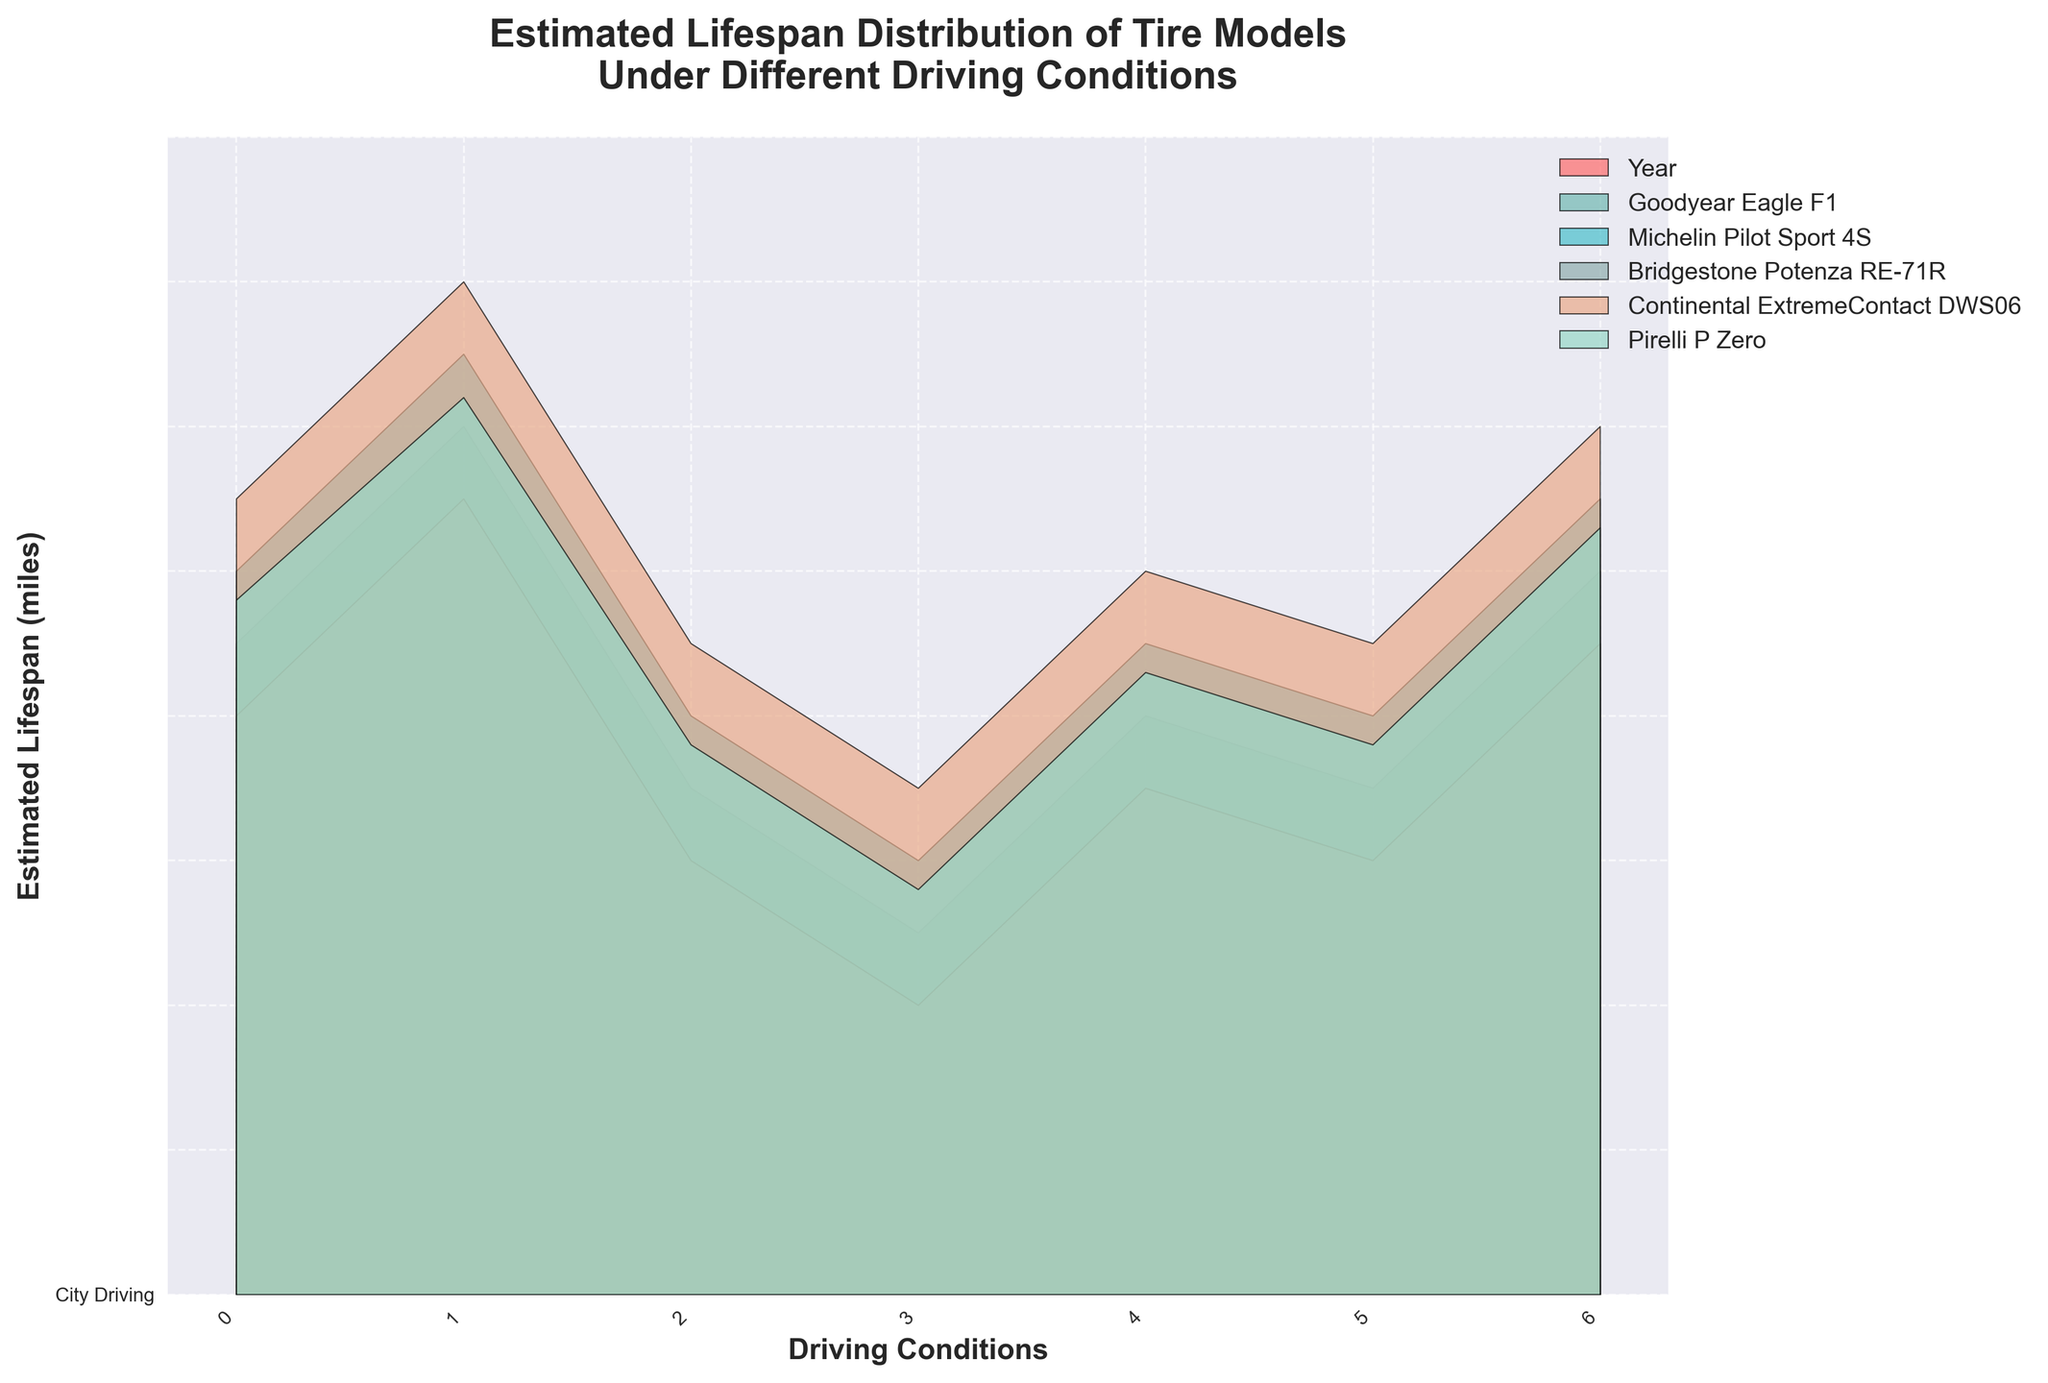What is the estimated lifespan of the Pirelli P Zero tires under city driving conditions? The estimated lifespan of the Pirelli P Zero tires under city driving conditions can be seen as the value corresponding to City Driving in the Pirelli P Zero line.
Answer: 48,000 miles Which tire model has the highest estimated lifespan under off-road driving conditions? Look at the off-road driving condition values for all tire models and compare them. The highest value is for Continental ExtremeContact DWS06.
Answer: Continental ExtremeContact DWS06 What is the difference in estimated lifespan of the Goodyear Eagle F1 between highway driving and wet conditions? The estimated lifespan for the Goodyear Eagle F1 in highway driving is 60,000 miles, and in wet conditions, it's 40,000 miles. The difference is 60,000 - 40,000.
Answer: 20,000 miles Which driving condition provides the lowest estimated lifespan for Bridgestone Potenza RE-71R tires? Compare the values for Bridgestone Potenza RE-71R across all driving conditions. Performance Driving has the lowest value.
Answer: Performance Driving What is the average estimated lifespan of Michelin Pilot Sport 4S under city, highway, and off-road driving conditions? Add the lifespans under city (50,000), highway (65,000), and off-road (30,000) driving conditions and divide by the number of conditions (3). (50,000 + 65,000 + 30,000)/3
Answer: 48,333 miles Under which climate condition do Goodyear Eagle F1 tires have higher estimated lifespan, cold or hot? Compare the values of the Goodyear Eagle F1 under cold climate (35,000 miles) and hot climate (50,000 miles) conditions. Hot climate has a higher lifespan.
Answer: Hot climate How much longer do Continental ExtremeContact DWS06 tires last under highway driving conditions compared to performance driving conditions? The estimated lifespans under highway driving (70,000 miles) and performance driving (45,000 miles) are compared. Subtract the performance driving lifespan from the highway driving lifespan. 70,000 - 45,000
Answer: 25,000 miles Which tire model shows the smallest variation in estimated lifespan across all given driving conditions? By observing the range of values for each tire model across all driving conditions and calculating the range (max value - min value), we find that Goodyear Eagle F1 has the smallest variation (from 25,000 to 60,000 miles).
Answer: Goodyear Eagle F1 